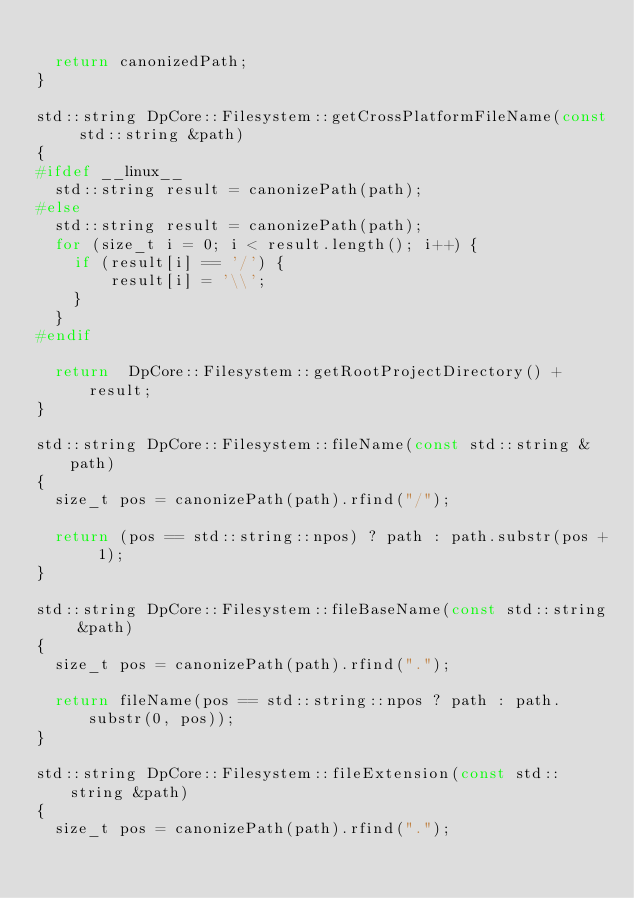Convert code to text. <code><loc_0><loc_0><loc_500><loc_500><_C++_>
  return canonizedPath;
}

std::string DpCore::Filesystem::getCrossPlatformFileName(const std::string &path)
{
#ifdef __linux__
  std::string result = canonizePath(path);
#else
  std::string result = canonizePath(path);
  for (size_t i = 0; i < result.length(); i++) {
    if (result[i] == '/') {
        result[i] = '\\';
    }
  }
#endif

  return  DpCore::Filesystem::getRootProjectDirectory() + result;
}

std::string DpCore::Filesystem::fileName(const std::string &path)
{
  size_t pos = canonizePath(path).rfind("/");

  return (pos == std::string::npos) ? path : path.substr(pos + 1);
}

std::string DpCore::Filesystem::fileBaseName(const std::string &path)
{
  size_t pos = canonizePath(path).rfind(".");

  return fileName(pos == std::string::npos ? path : path.substr(0, pos));
}

std::string DpCore::Filesystem::fileExtension(const std::string &path)
{
  size_t pos = canonizePath(path).rfind(".");
</code> 